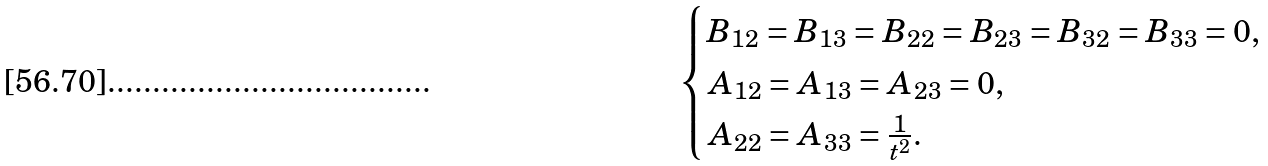<formula> <loc_0><loc_0><loc_500><loc_500>\begin{cases} B _ { 1 2 } = B _ { 1 3 } = B _ { 2 2 } = B _ { 2 3 } = B _ { 3 2 } = B _ { 3 3 } = 0 , \\ A _ { 1 2 } = A _ { 1 3 } = A _ { 2 3 } = 0 , \\ A _ { 2 2 } = A _ { 3 3 } = \frac { 1 } { t ^ { 2 } } . \end{cases}</formula> 